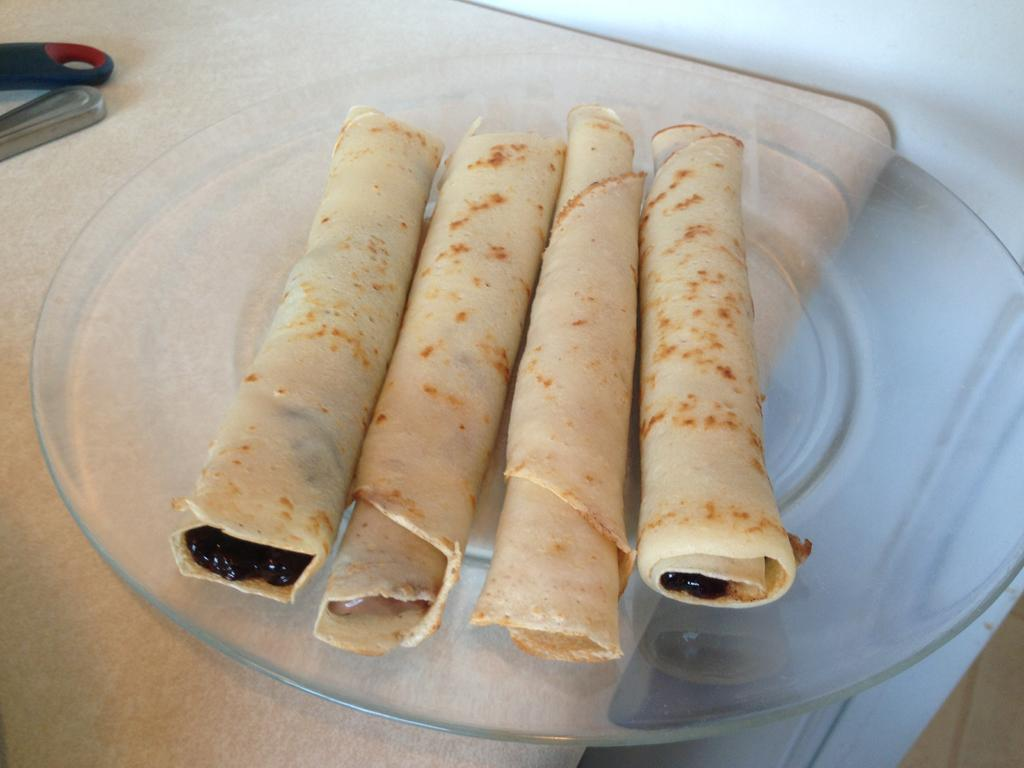What is present on the surface in the image? There is a plate in the image. What is on the plate? There are four rolls on the plate. Can you describe the position of the plate in the image? The plate is on a surface. What type of screw can be seen in the garden in the image? There is no screw or garden present in the image; it only features a plate with four rolls on it. 